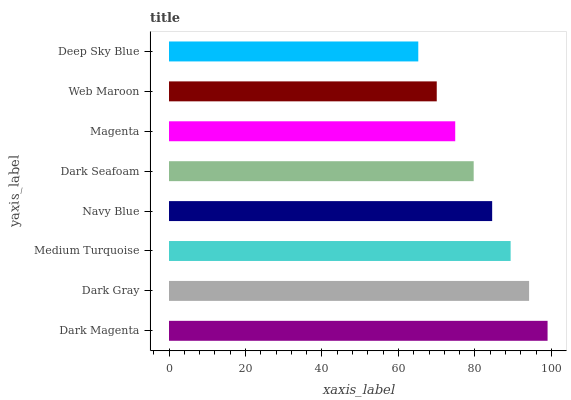Is Deep Sky Blue the minimum?
Answer yes or no. Yes. Is Dark Magenta the maximum?
Answer yes or no. Yes. Is Dark Gray the minimum?
Answer yes or no. No. Is Dark Gray the maximum?
Answer yes or no. No. Is Dark Magenta greater than Dark Gray?
Answer yes or no. Yes. Is Dark Gray less than Dark Magenta?
Answer yes or no. Yes. Is Dark Gray greater than Dark Magenta?
Answer yes or no. No. Is Dark Magenta less than Dark Gray?
Answer yes or no. No. Is Navy Blue the high median?
Answer yes or no. Yes. Is Dark Seafoam the low median?
Answer yes or no. Yes. Is Dark Magenta the high median?
Answer yes or no. No. Is Dark Magenta the low median?
Answer yes or no. No. 